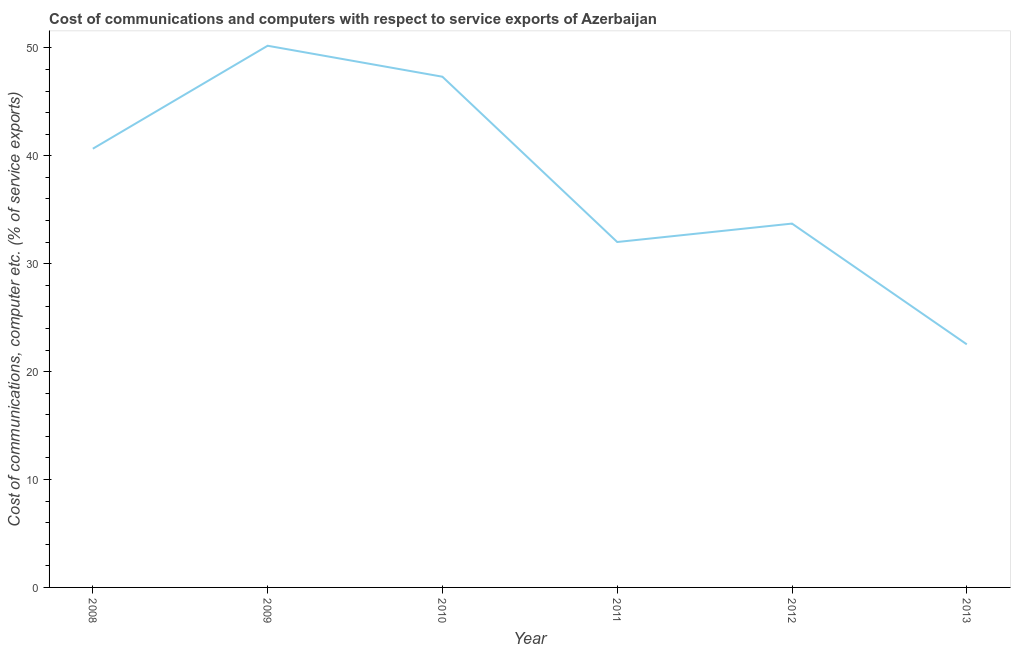What is the cost of communications and computer in 2011?
Your response must be concise. 32.01. Across all years, what is the maximum cost of communications and computer?
Your answer should be compact. 50.2. Across all years, what is the minimum cost of communications and computer?
Keep it short and to the point. 22.53. What is the sum of the cost of communications and computer?
Ensure brevity in your answer.  226.45. What is the difference between the cost of communications and computer in 2011 and 2013?
Offer a very short reply. 9.48. What is the average cost of communications and computer per year?
Your answer should be compact. 37.74. What is the median cost of communications and computer?
Your answer should be very brief. 37.19. In how many years, is the cost of communications and computer greater than 46 %?
Your answer should be very brief. 2. Do a majority of the years between 2009 and 2010 (inclusive) have cost of communications and computer greater than 16 %?
Ensure brevity in your answer.  Yes. What is the ratio of the cost of communications and computer in 2009 to that in 2010?
Provide a succinct answer. 1.06. Is the cost of communications and computer in 2008 less than that in 2011?
Keep it short and to the point. No. What is the difference between the highest and the second highest cost of communications and computer?
Your response must be concise. 2.87. Is the sum of the cost of communications and computer in 2011 and 2012 greater than the maximum cost of communications and computer across all years?
Your response must be concise. Yes. What is the difference between the highest and the lowest cost of communications and computer?
Your answer should be compact. 27.67. How many lines are there?
Keep it short and to the point. 1. How many years are there in the graph?
Keep it short and to the point. 6. What is the difference between two consecutive major ticks on the Y-axis?
Give a very brief answer. 10. What is the title of the graph?
Provide a succinct answer. Cost of communications and computers with respect to service exports of Azerbaijan. What is the label or title of the Y-axis?
Provide a succinct answer. Cost of communications, computer etc. (% of service exports). What is the Cost of communications, computer etc. (% of service exports) in 2008?
Offer a terse response. 40.66. What is the Cost of communications, computer etc. (% of service exports) of 2009?
Provide a succinct answer. 50.2. What is the Cost of communications, computer etc. (% of service exports) of 2010?
Provide a short and direct response. 47.33. What is the Cost of communications, computer etc. (% of service exports) in 2011?
Provide a short and direct response. 32.01. What is the Cost of communications, computer etc. (% of service exports) of 2012?
Your response must be concise. 33.72. What is the Cost of communications, computer etc. (% of service exports) in 2013?
Offer a very short reply. 22.53. What is the difference between the Cost of communications, computer etc. (% of service exports) in 2008 and 2009?
Your answer should be very brief. -9.54. What is the difference between the Cost of communications, computer etc. (% of service exports) in 2008 and 2010?
Make the answer very short. -6.67. What is the difference between the Cost of communications, computer etc. (% of service exports) in 2008 and 2011?
Keep it short and to the point. 8.65. What is the difference between the Cost of communications, computer etc. (% of service exports) in 2008 and 2012?
Ensure brevity in your answer.  6.94. What is the difference between the Cost of communications, computer etc. (% of service exports) in 2008 and 2013?
Your answer should be compact. 18.13. What is the difference between the Cost of communications, computer etc. (% of service exports) in 2009 and 2010?
Your answer should be compact. 2.87. What is the difference between the Cost of communications, computer etc. (% of service exports) in 2009 and 2011?
Give a very brief answer. 18.19. What is the difference between the Cost of communications, computer etc. (% of service exports) in 2009 and 2012?
Offer a very short reply. 16.48. What is the difference between the Cost of communications, computer etc. (% of service exports) in 2009 and 2013?
Give a very brief answer. 27.67. What is the difference between the Cost of communications, computer etc. (% of service exports) in 2010 and 2011?
Keep it short and to the point. 15.32. What is the difference between the Cost of communications, computer etc. (% of service exports) in 2010 and 2012?
Provide a succinct answer. 13.61. What is the difference between the Cost of communications, computer etc. (% of service exports) in 2010 and 2013?
Your answer should be very brief. 24.8. What is the difference between the Cost of communications, computer etc. (% of service exports) in 2011 and 2012?
Provide a short and direct response. -1.71. What is the difference between the Cost of communications, computer etc. (% of service exports) in 2011 and 2013?
Give a very brief answer. 9.48. What is the difference between the Cost of communications, computer etc. (% of service exports) in 2012 and 2013?
Offer a terse response. 11.19. What is the ratio of the Cost of communications, computer etc. (% of service exports) in 2008 to that in 2009?
Give a very brief answer. 0.81. What is the ratio of the Cost of communications, computer etc. (% of service exports) in 2008 to that in 2010?
Your answer should be very brief. 0.86. What is the ratio of the Cost of communications, computer etc. (% of service exports) in 2008 to that in 2011?
Your answer should be very brief. 1.27. What is the ratio of the Cost of communications, computer etc. (% of service exports) in 2008 to that in 2012?
Provide a succinct answer. 1.21. What is the ratio of the Cost of communications, computer etc. (% of service exports) in 2008 to that in 2013?
Your answer should be very brief. 1.8. What is the ratio of the Cost of communications, computer etc. (% of service exports) in 2009 to that in 2010?
Ensure brevity in your answer.  1.06. What is the ratio of the Cost of communications, computer etc. (% of service exports) in 2009 to that in 2011?
Make the answer very short. 1.57. What is the ratio of the Cost of communications, computer etc. (% of service exports) in 2009 to that in 2012?
Offer a very short reply. 1.49. What is the ratio of the Cost of communications, computer etc. (% of service exports) in 2009 to that in 2013?
Provide a short and direct response. 2.23. What is the ratio of the Cost of communications, computer etc. (% of service exports) in 2010 to that in 2011?
Your answer should be very brief. 1.48. What is the ratio of the Cost of communications, computer etc. (% of service exports) in 2010 to that in 2012?
Your answer should be very brief. 1.4. What is the ratio of the Cost of communications, computer etc. (% of service exports) in 2010 to that in 2013?
Provide a succinct answer. 2.1. What is the ratio of the Cost of communications, computer etc. (% of service exports) in 2011 to that in 2012?
Your answer should be very brief. 0.95. What is the ratio of the Cost of communications, computer etc. (% of service exports) in 2011 to that in 2013?
Provide a short and direct response. 1.42. What is the ratio of the Cost of communications, computer etc. (% of service exports) in 2012 to that in 2013?
Keep it short and to the point. 1.5. 